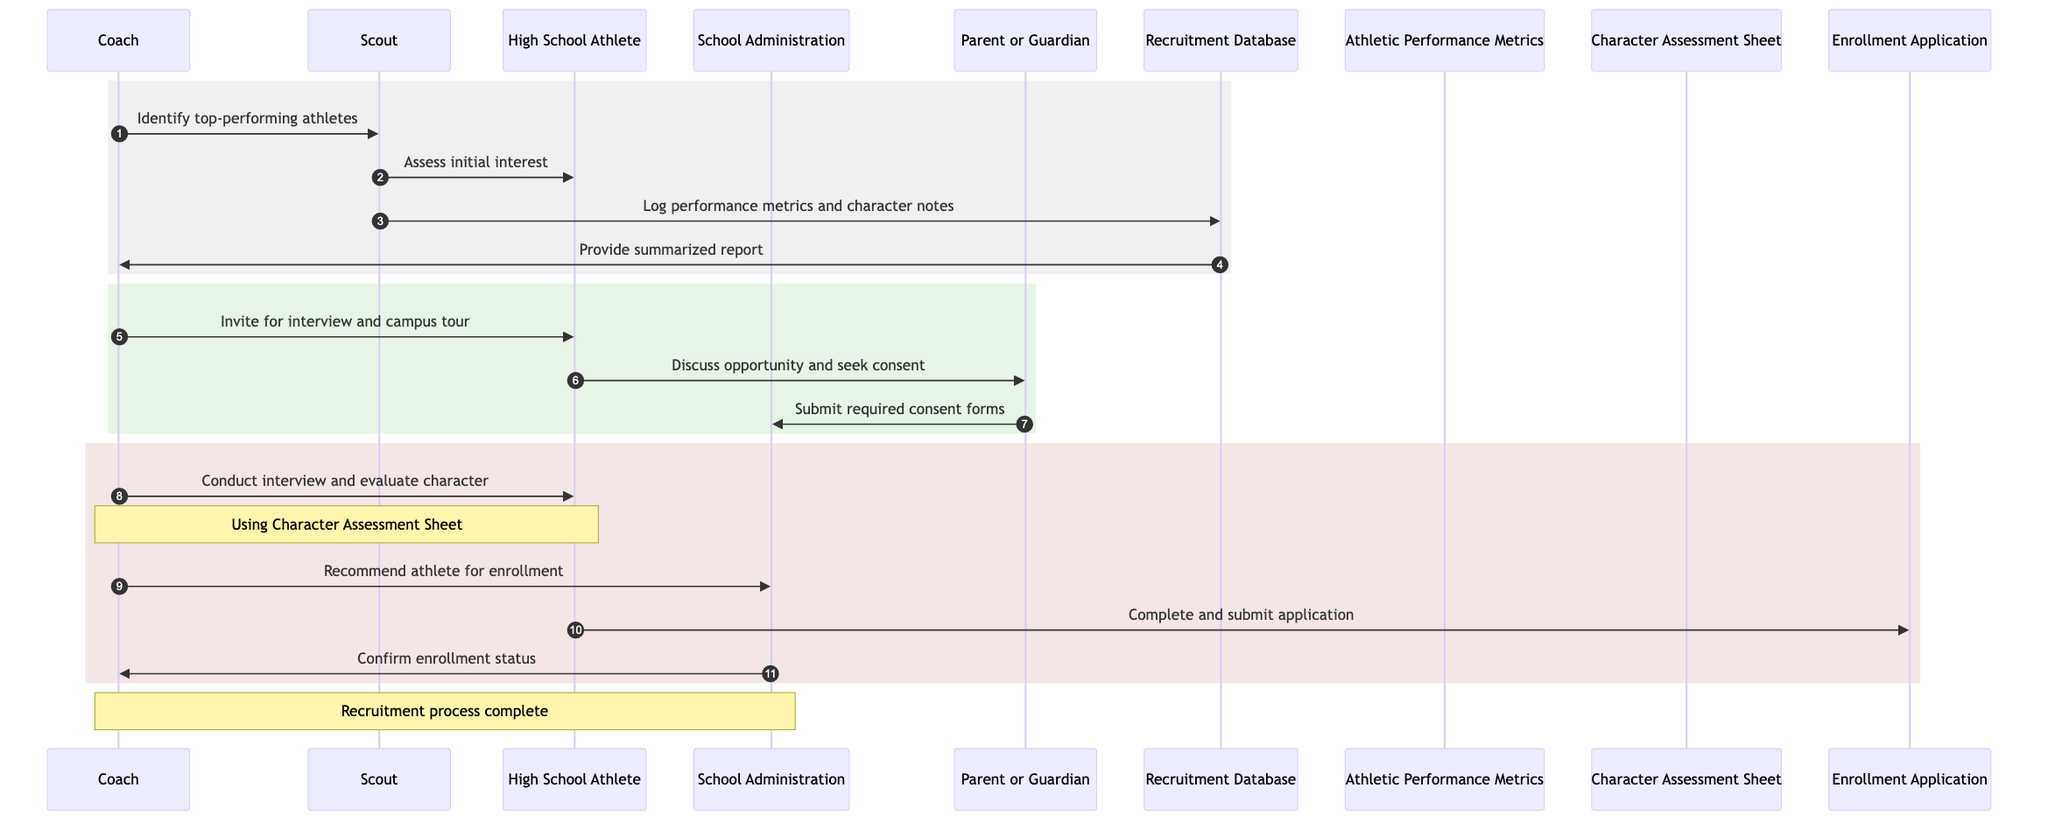What is the first action the Coach takes in the recruitment process? The Coach instructs the Scout to identify top-performing athletes in local competitions, which is the initial step in the recruitment process.
Answer: Identify top-performing athletes How many actors are involved in the recruitment process? The diagram lists a total of five actors: Coach, Scout, High School Athlete, School Administration, and Parent or Guardian.
Answer: Five What does the Scout do after approaching the High School Athlete? After assessing initial interest, the Scout logs the athlete's performance metrics and character notes into the Recruitment Database.
Answer: Log performance metrics and character notes Which document does the Parent or Guardian submit after discussing with the High School Athlete? After discussing the opportunity with the High School Athlete, the Parent or Guardian submits the required consent forms to the School Administration.
Answer: Required consent forms What is used by the Coach to evaluate the character of the High School Athlete? The Coach uses the Character Assessment Sheet to conduct the interview and evaluate the athlete's character during the recruitment process.
Answer: Character Assessment Sheet What does the School Administration confirm after the High School Athlete submits the enrollment application? After the enrollment application is submitted, the School Administration confirms the athlete's enrollment status to the Coach.
Answer: Confirm enrollment status How many steps are used before the athlete completes the enrollment application? There are four steps before the athlete completes the enrollment application: identifying athletes, assessing interest, logging metrics and notes, and inviting for an interview.
Answer: Four steps What role does the Recruitment Database play in the recruitment process? The Recruitment Database provides a summarized report of potential recruits to the Coach, which helps in making decisions regarding recruitment.
Answer: Summarized report of potential recruits What follows the Coach's recommendation for athlete enrollment? After the Coach recommends the athlete for enrollment, the High School Athlete completes and submits the enrollment application as the next step in the process.
Answer: Complete and submit enrollment application 